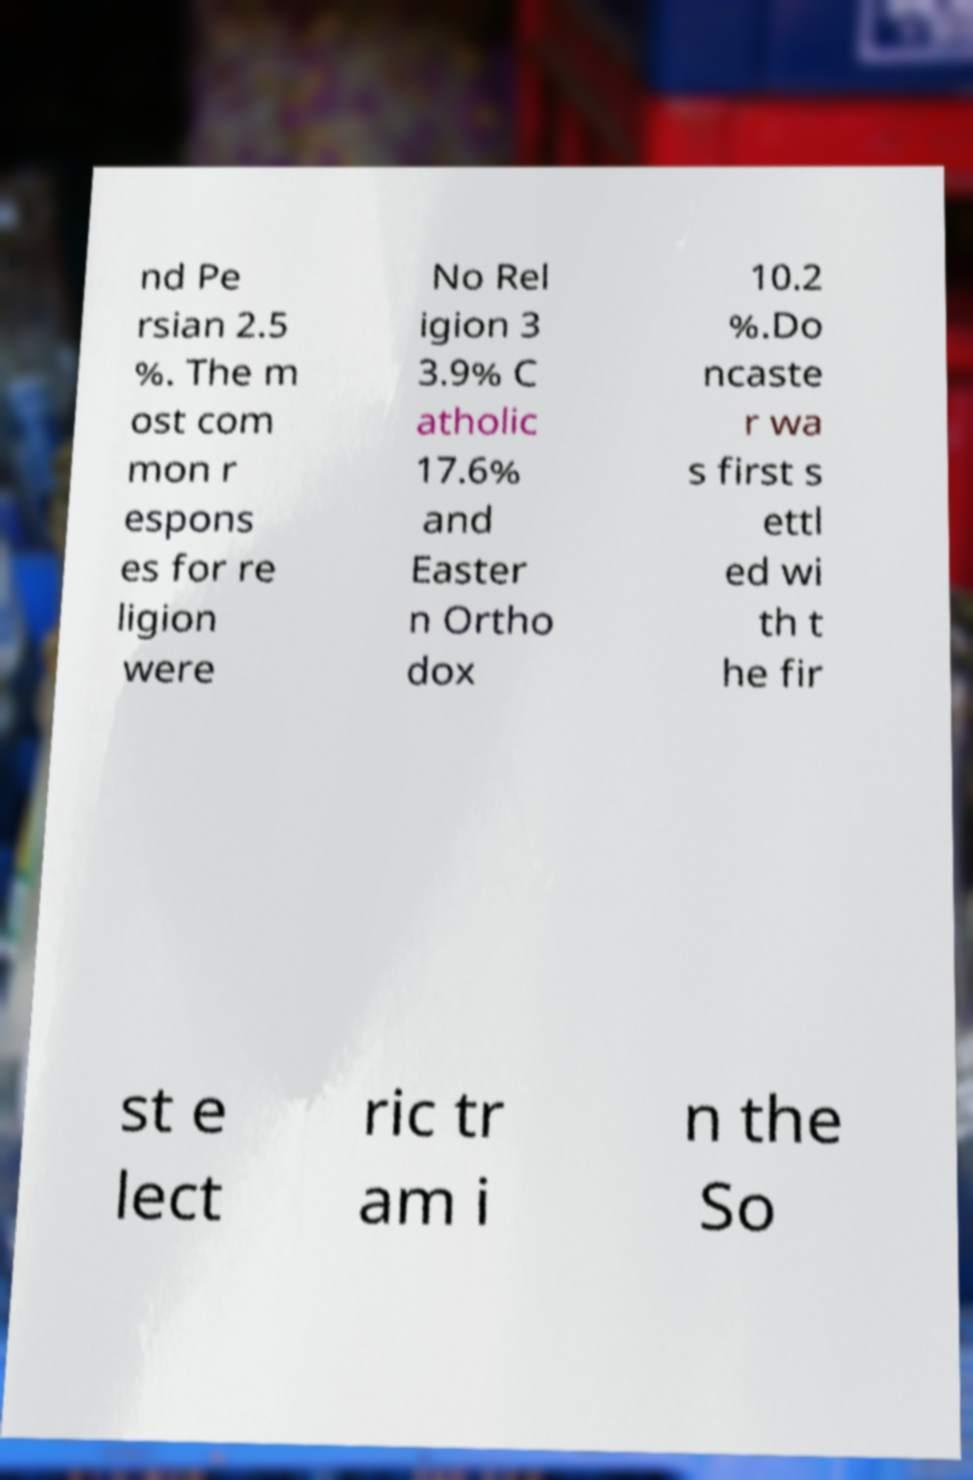There's text embedded in this image that I need extracted. Can you transcribe it verbatim? nd Pe rsian 2.5 %. The m ost com mon r espons es for re ligion were No Rel igion 3 3.9% C atholic 17.6% and Easter n Ortho dox 10.2 %.Do ncaste r wa s first s ettl ed wi th t he fir st e lect ric tr am i n the So 